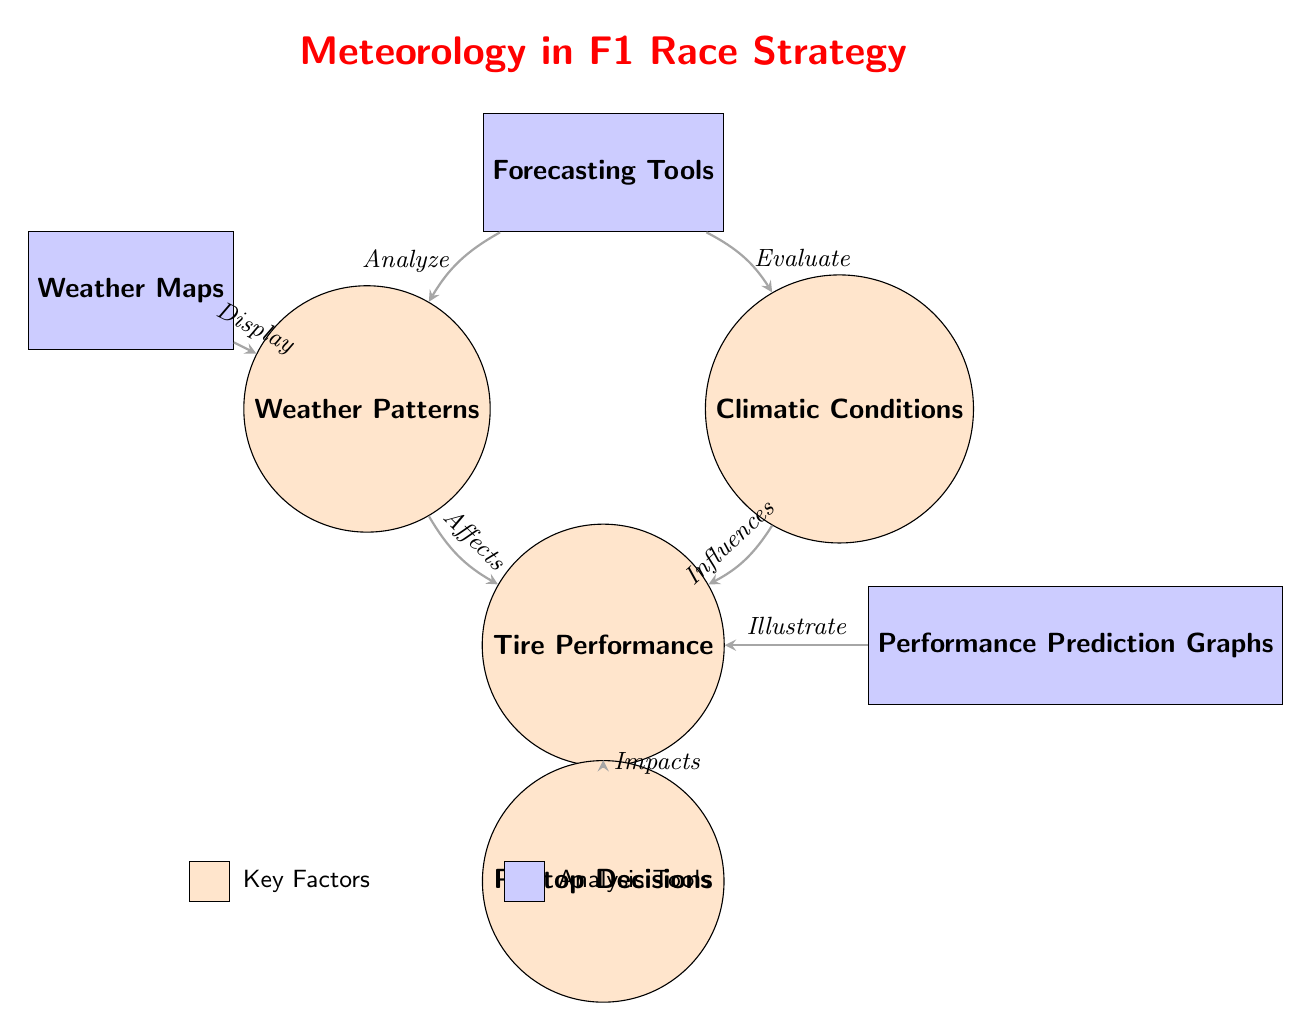What node represents tire performance? The diagram shows that the node labeled "Tire Performance" is located at coordinates (3,-3). This can be identified simply by looking for the node with this specific label in the diagram.
Answer: Tire Performance How many main nodes are present in the diagram? By counting all the unique nodes in the diagram, we identify five main nodes: Weather Patterns, Climatic Conditions, Tire Performance, Pitstop Decisions, and Forecasting Tools. Hence, the total count is five.
Answer: 5 What do weather maps display in the context of this diagram? The diagram indicates that weather maps display "Weather Patterns," which is represented as a directed edge from the node "Weather Maps" to "Weather Patterns." This implies a direct relationship regarding information conveyed.
Answer: Weather Patterns How does tire performance impact pitstop decisions? The diagram illustrates that "Tire Performance" impacts "Pitstop Decisions" through a directed edge. This indicates that changes or results in tire performance will influence when and how often pitstops are made during a race.
Answer: Impacts What analysis tools are mentioned in the diagram? The analysis tools indicated in the diagram are "Forecasting Tools" and "Weather Maps," as shown by their respective nodes. Both of these tools are connected to analyzing various meteorological aspects which affect race strategy.
Answer: Forecasting Tools, Weather Maps What does the flow between climatic conditions and tire performance suggest? The diagram illustrates a directional relationship where "Climatic Conditions" influences "Tire Performance." This suggests that different climatic factors such as temperature and humidity can affect how tires perform during races.
Answer: Influences Which two nodes are analyzed by forecasting tools? The diagram shows that the "Forecasting Tools" node connects to both "Weather Patterns" and "Climatic Conditions." This indicates that forecasting tools analyze each of these meteorological aspects.
Answer: Weather Patterns, Climatic Conditions What is illustrated by performance prediction graphs? The diagram connects the "Performance Prediction Graphs" node to the "Tire Performance" node, indicating that these graphs are used to illustrate and predict the performance metrics of tires during the race.
Answer: Illustrate 